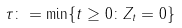Convert formula to latex. <formula><loc_0><loc_0><loc_500><loc_500>\tau \colon = \min \{ t \geq 0 \colon Z _ { t } = 0 \}</formula> 